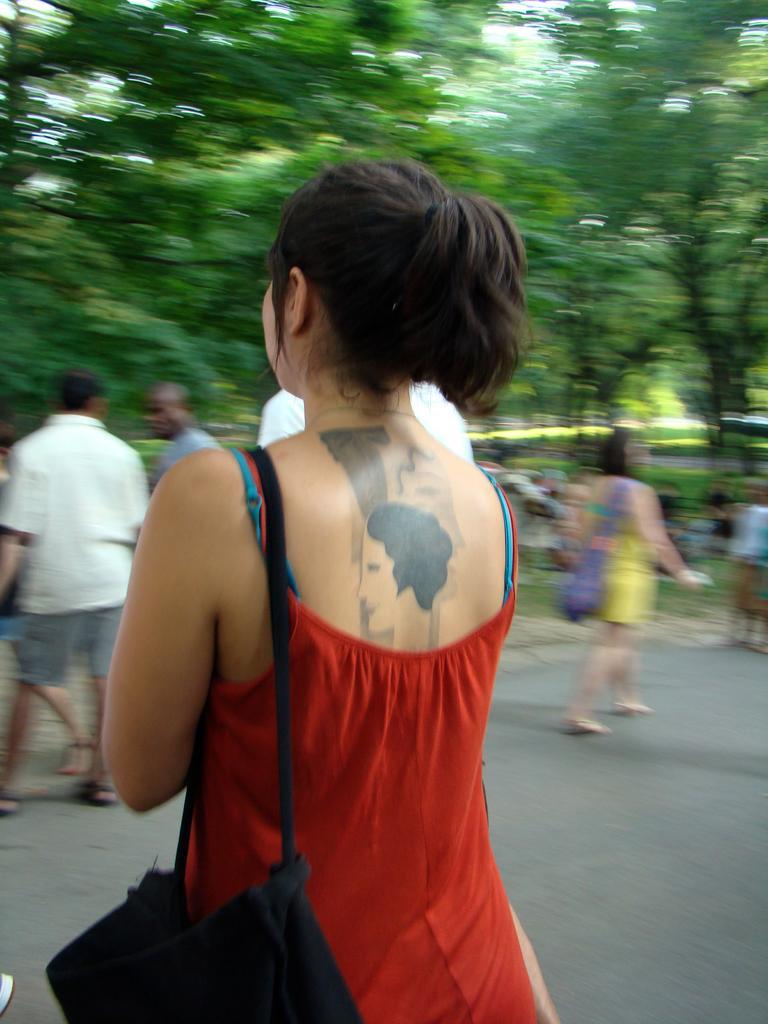Could you give a brief overview of what you see in this image? In the image in the center we can see one woman standing and she is holding handbag. In the background we can see trees,road,grass and few peoples were walking on the road. 